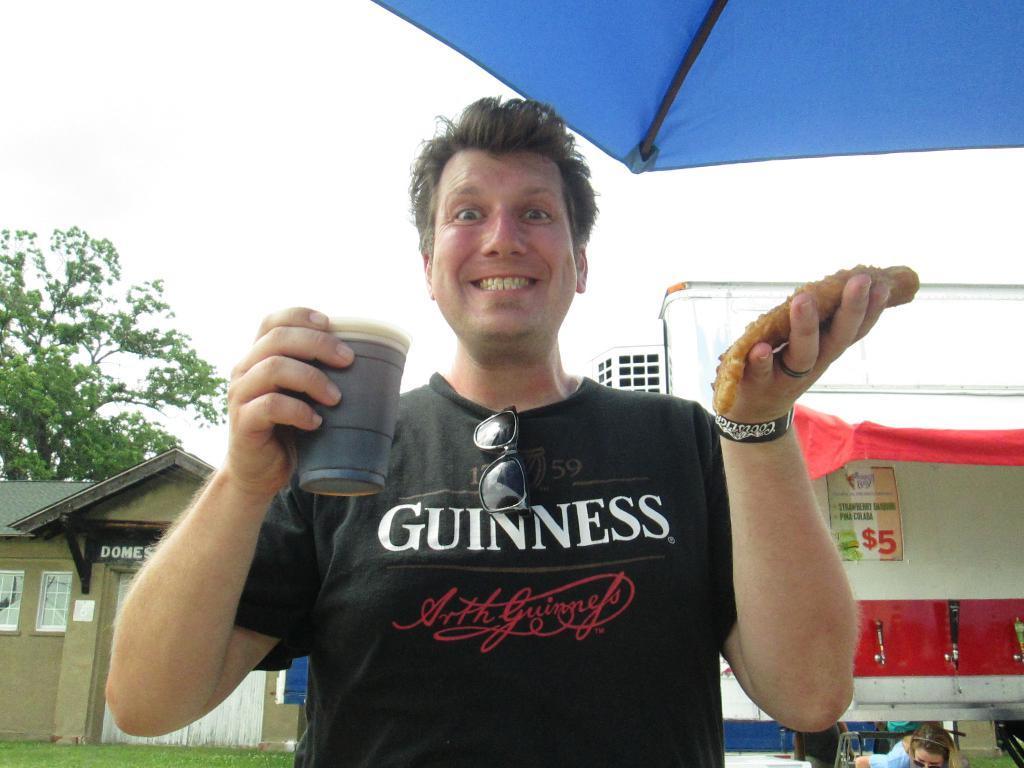Describe this image in one or two sentences. In this image we can see a person wearing black color T-shirt, goggles holding some food item and coffee glass in his hands and at the background of the image there are some houses, persons sitting there is a tree and at the top of the image there is clear sky and blue color umbrella. 